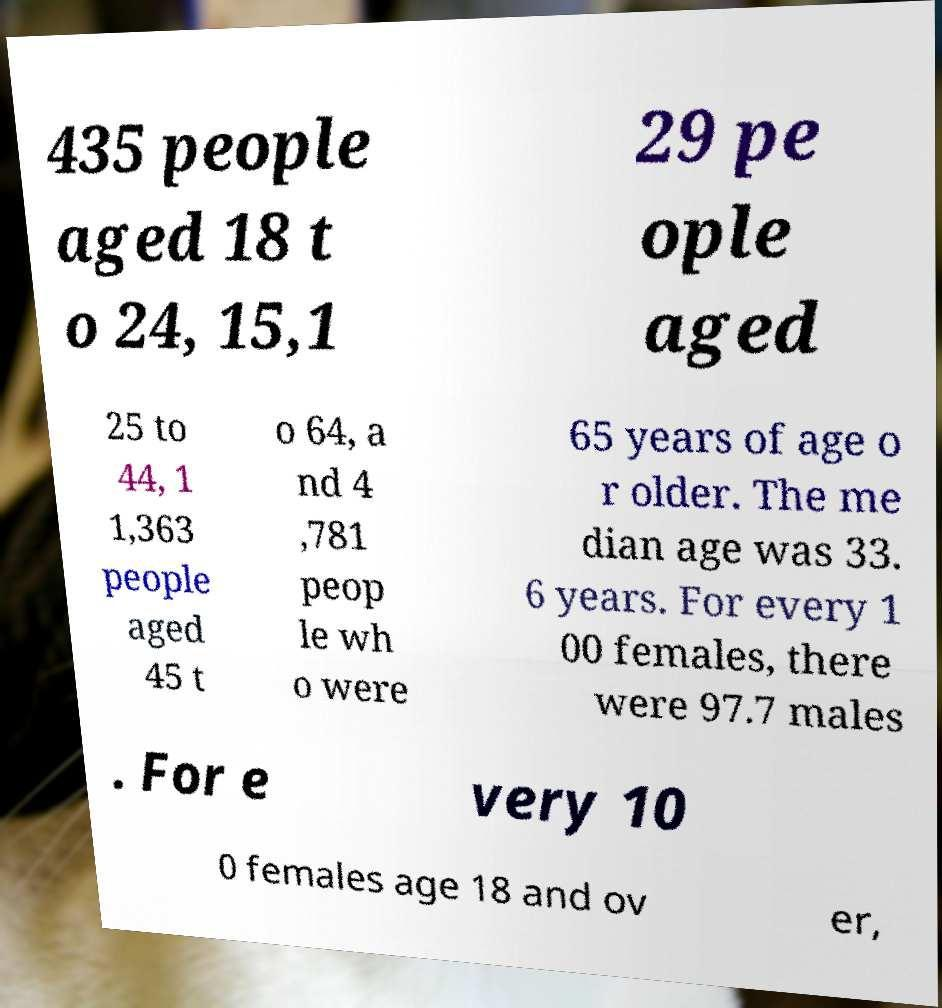Can you read and provide the text displayed in the image?This photo seems to have some interesting text. Can you extract and type it out for me? 435 people aged 18 t o 24, 15,1 29 pe ople aged 25 to 44, 1 1,363 people aged 45 t o 64, a nd 4 ,781 peop le wh o were 65 years of age o r older. The me dian age was 33. 6 years. For every 1 00 females, there were 97.7 males . For e very 10 0 females age 18 and ov er, 